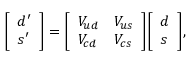<formula> <loc_0><loc_0><loc_500><loc_500>{ \left [ \begin{array} { l } { d ^ { \prime } } \\ { s ^ { \prime } } \end{array} \right ] } = { \left [ \begin{array} { l l } { V _ { u d } } & { V _ { u s } } \\ { V _ { c d } } & { V _ { c s } } \end{array} \right ] } { \left [ \begin{array} { l } { d } \\ { s } \end{array} \right ] } ,</formula> 